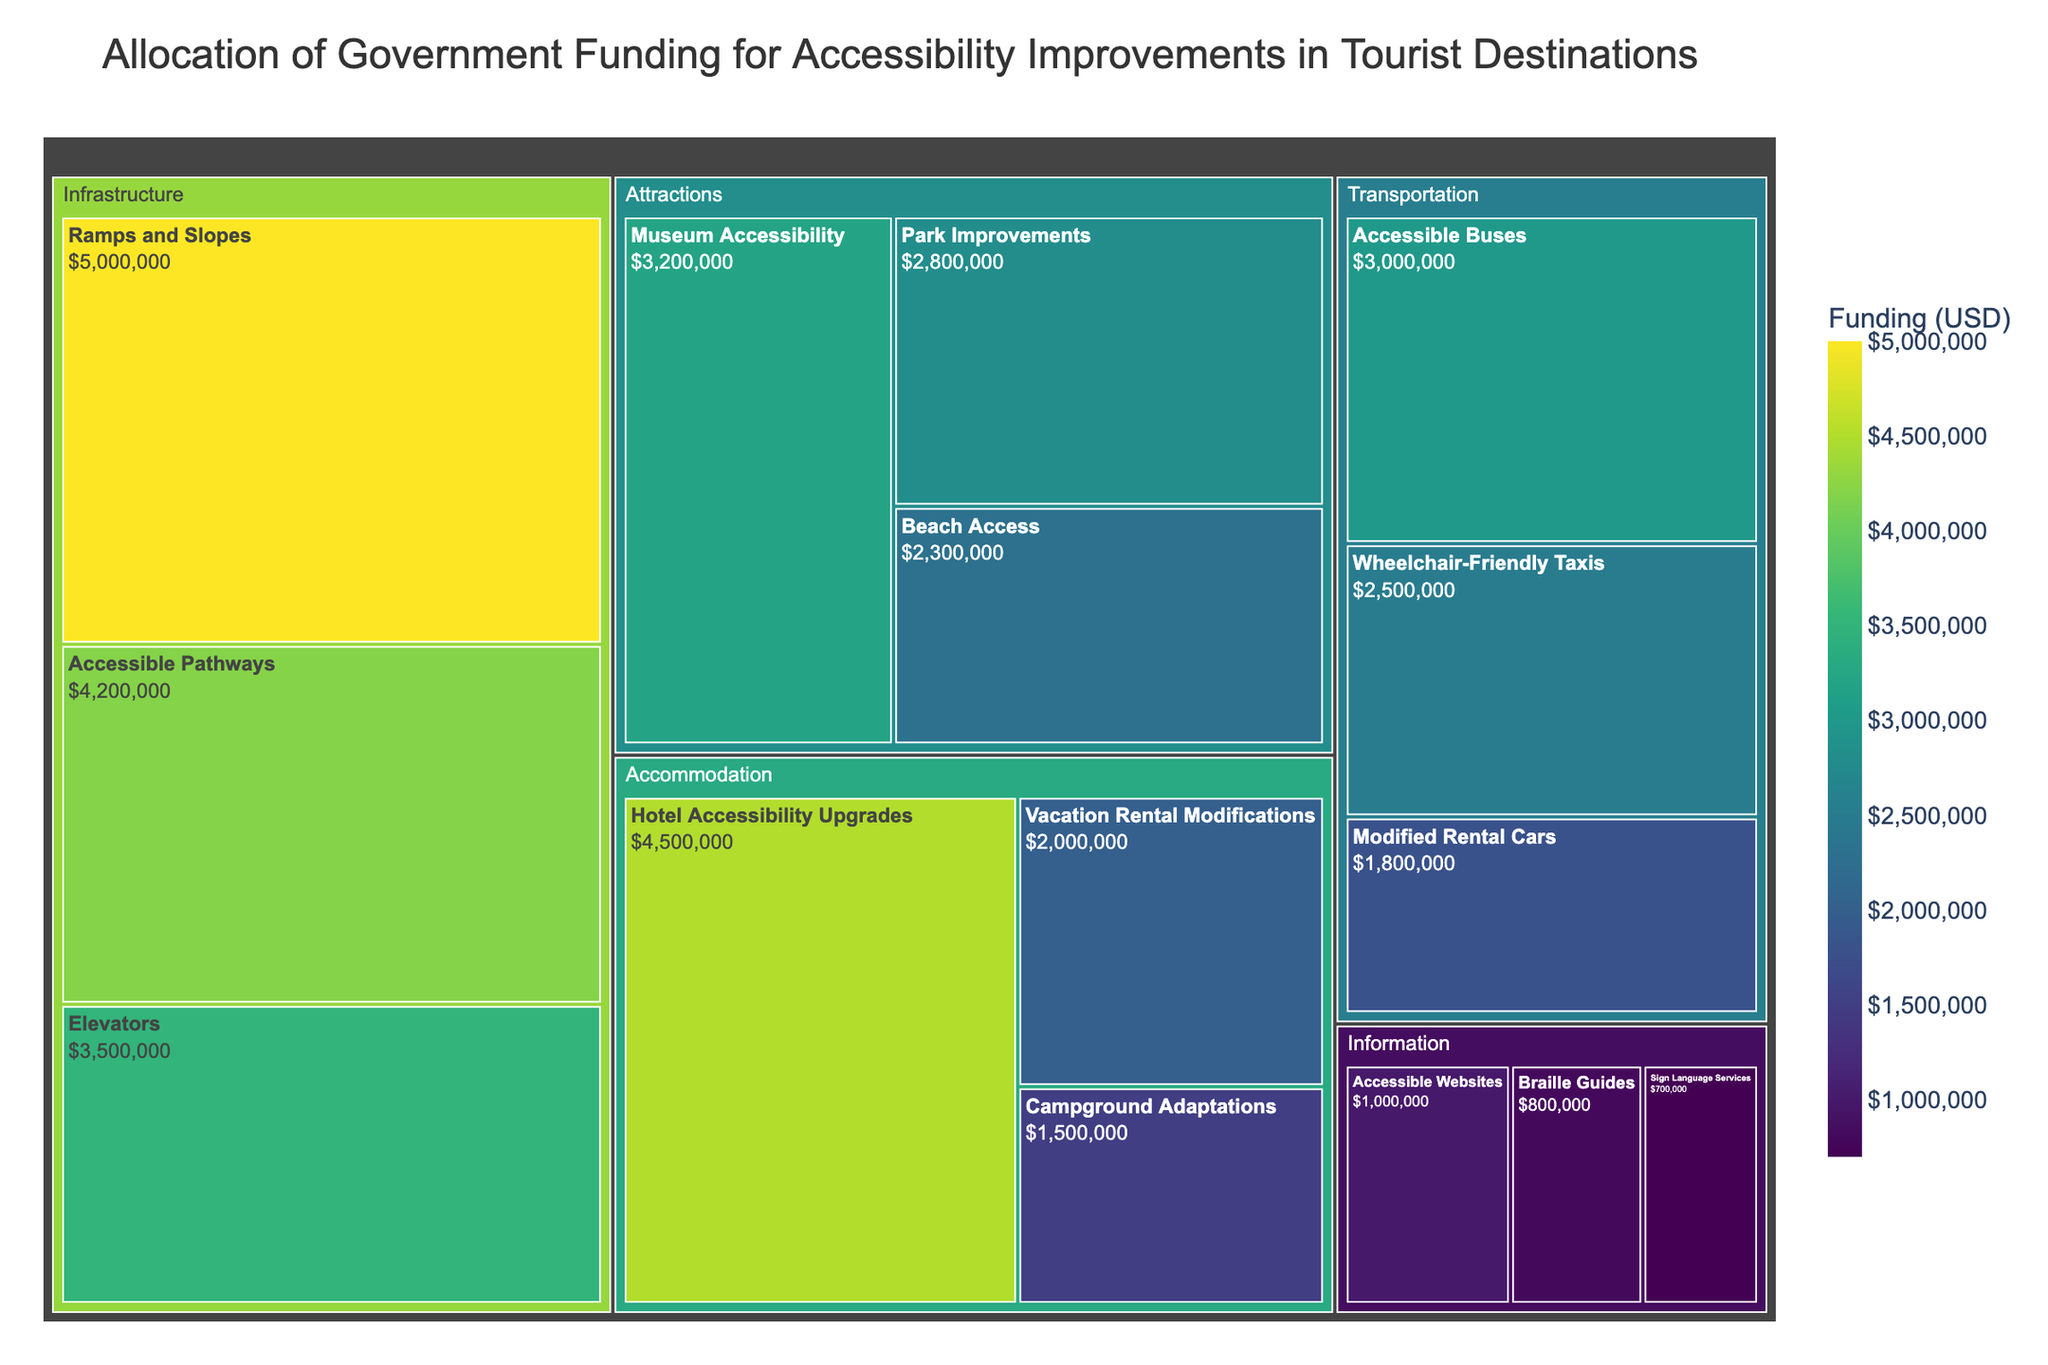What is the title of the treemap? The title can be found at the top of the figure. It provides a summary of what the treemap represents.
Answer: Allocation of Government Funding for Accessibility Improvements in Tourist Destinations Which category received the highest funding? Observe the size of each category, as larger sections in a treemap signify higher funding.
Answer: Infrastructure What is the total funding allocated to Transportation? Sum the funding amounts for Accessible Buses, Wheelchair-Friendly Taxis, and Modified Rental Cars. $3,000,000 + $2,500,000 + $1,800,000 = $7,300,000.
Answer: $7,300,000 Which subcategory received the least funding? Identify the smallest segment within all categories.
Answer: Sign Language Services Compare the funding allocated to Museum Accessibility and Beach Access. Which one received more? Check the sizes of the segments for both subcategories and compare the values. Museum Accessibility has $3,200,000 and Beach Access has $2,300,000.
Answer: Museum Accessibility What is the difference in funding between Accessible Pathways and Accessible Buses? Subtract the funding amount for Accessible Buses from that of Accessible Pathways. $4,200,000 - $3,000,000 = $1,200,000.
Answer: $1,200,000 What is the total funding allocated to Information? Sum the funding amounts for Accessible Websites, Braille Guides, and Sign Language Services. $1,000,000 + $800,000 + $700,000 = $2,500,000.
Answer: $2,500,000 Which category has the most diversity in subcategory funding amounts? Examine which category has subcategories with the most varied sizes and funding levels.
Answer: Information How does the funding for Hotel Accessibility Upgrades compare to the funding for the entire category of Attractions? First, sum the funding for all subcategories in Attractions: $3,200,000 (Museum Accessibility) + $2,800,000 (Park Improvements) + $2,300,000 (Beach Access) = $8,300,000. Then compare it with Hotel Accessibility Upgrades' funding of $4,500,000. Attractions ($8,300,000) is greater.
Answer: Attractions received more What is the average funding allocated to the subcategories within Accommodation? Total the funding for all subcategories in Accommodation and divide by the number of subcategories. ($4,500,000 + $2,000,000 + $1,500,000) / 3 = $8,000,000 / 3 ≈ $2,666,667.
Answer: ≈ $2,666,667 